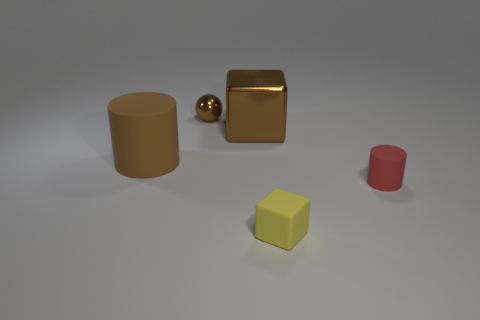Add 3 cyan spheres. How many objects exist? 8 Subtract all balls. How many objects are left? 4 Subtract all large cyan matte things. Subtract all metal balls. How many objects are left? 4 Add 2 tiny red matte cylinders. How many tiny red matte cylinders are left? 3 Add 3 big yellow matte things. How many big yellow matte things exist? 3 Subtract 1 red cylinders. How many objects are left? 4 